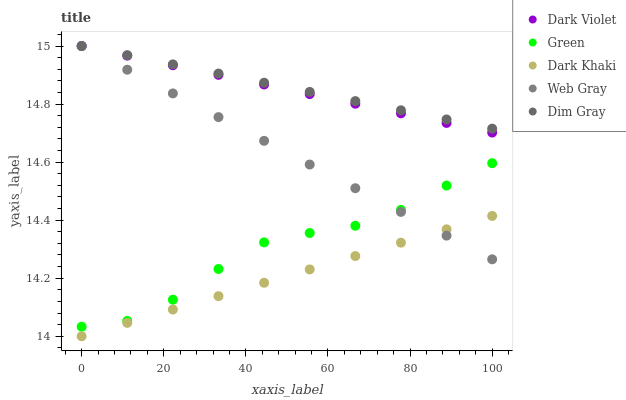Does Dark Khaki have the minimum area under the curve?
Answer yes or no. Yes. Does Dim Gray have the maximum area under the curve?
Answer yes or no. Yes. Does Web Gray have the minimum area under the curve?
Answer yes or no. No. Does Web Gray have the maximum area under the curve?
Answer yes or no. No. Is Web Gray the smoothest?
Answer yes or no. Yes. Is Green the roughest?
Answer yes or no. Yes. Is Dim Gray the smoothest?
Answer yes or no. No. Is Dim Gray the roughest?
Answer yes or no. No. Does Dark Khaki have the lowest value?
Answer yes or no. Yes. Does Web Gray have the lowest value?
Answer yes or no. No. Does Dark Violet have the highest value?
Answer yes or no. Yes. Does Green have the highest value?
Answer yes or no. No. Is Dark Khaki less than Dim Gray?
Answer yes or no. Yes. Is Green greater than Dark Khaki?
Answer yes or no. Yes. Does Dark Violet intersect Web Gray?
Answer yes or no. Yes. Is Dark Violet less than Web Gray?
Answer yes or no. No. Is Dark Violet greater than Web Gray?
Answer yes or no. No. Does Dark Khaki intersect Dim Gray?
Answer yes or no. No. 